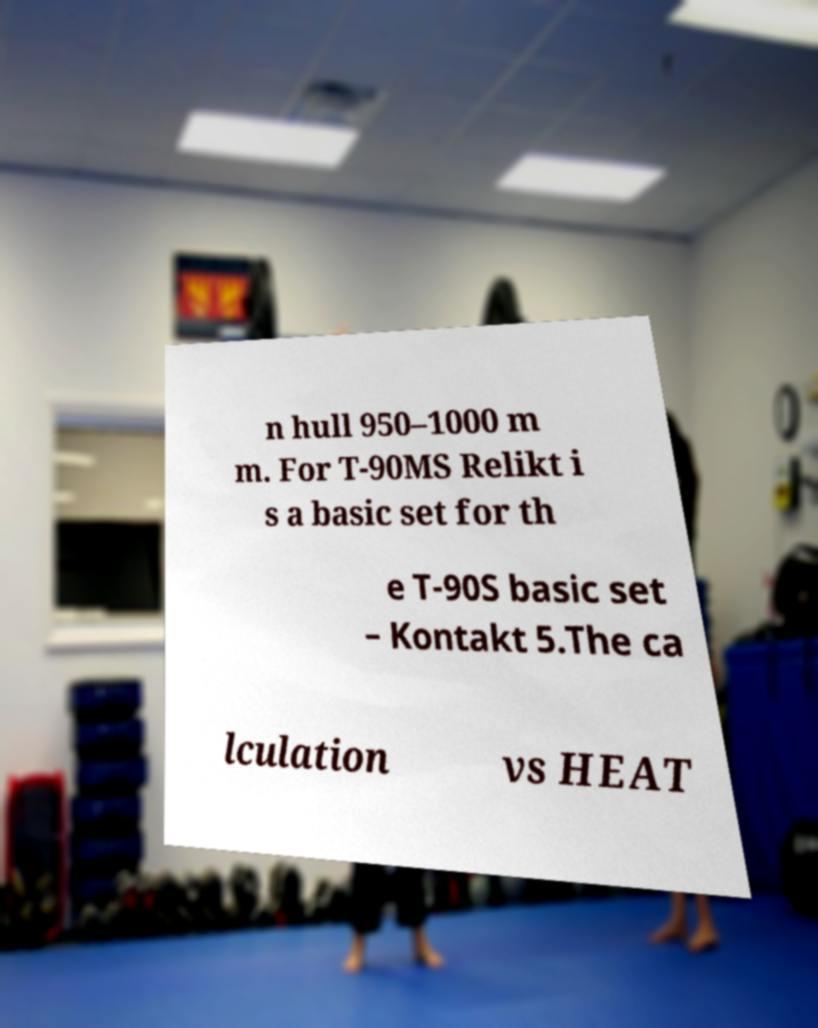There's text embedded in this image that I need extracted. Can you transcribe it verbatim? n hull 950–1000 m m. For T-90MS Relikt i s a basic set for th e T-90S basic set – Kontakt 5.The ca lculation vs HEAT 